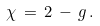<formula> <loc_0><loc_0><loc_500><loc_500>\chi \, = \, 2 \, - \, g \, .</formula> 